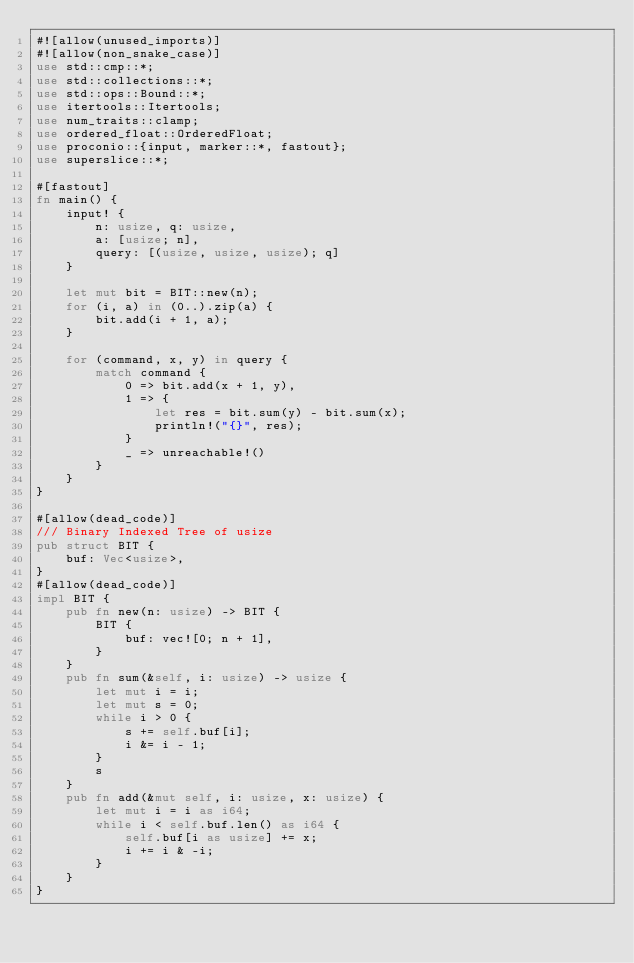Convert code to text. <code><loc_0><loc_0><loc_500><loc_500><_Rust_>#![allow(unused_imports)]
#![allow(non_snake_case)]
use std::cmp::*;
use std::collections::*;
use std::ops::Bound::*;
use itertools::Itertools;
use num_traits::clamp;
use ordered_float::OrderedFloat;
use proconio::{input, marker::*, fastout};
use superslice::*;

#[fastout]
fn main() {
    input! {
        n: usize, q: usize,
        a: [usize; n],
        query: [(usize, usize, usize); q]
    }

    let mut bit = BIT::new(n);
    for (i, a) in (0..).zip(a) {
        bit.add(i + 1, a);
    }

    for (command, x, y) in query {
        match command {
            0 => bit.add(x + 1, y),
            1 => {
                let res = bit.sum(y) - bit.sum(x);
                println!("{}", res);
            }
            _ => unreachable!()
        }
    }
}

#[allow(dead_code)]
/// Binary Indexed Tree of usize
pub struct BIT {
    buf: Vec<usize>,
}
#[allow(dead_code)]
impl BIT {
    pub fn new(n: usize) -> BIT {
        BIT {
            buf: vec![0; n + 1],
        }
    }
    pub fn sum(&self, i: usize) -> usize {
        let mut i = i;
        let mut s = 0;
        while i > 0 {
            s += self.buf[i];
            i &= i - 1;
        }
        s
    }
    pub fn add(&mut self, i: usize, x: usize) {
        let mut i = i as i64;
        while i < self.buf.len() as i64 {
            self.buf[i as usize] += x;
            i += i & -i;
        }
    }
}</code> 